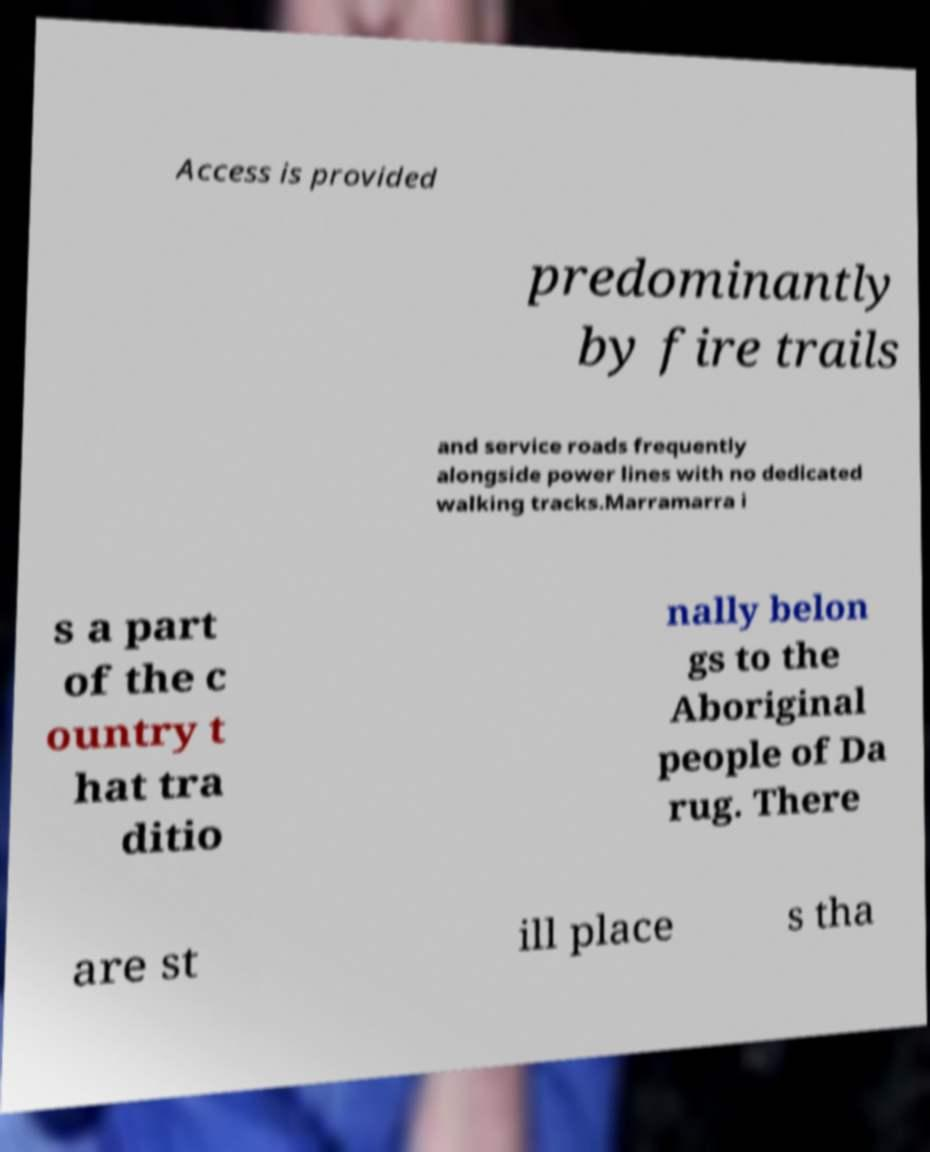What messages or text are displayed in this image? I need them in a readable, typed format. Access is provided predominantly by fire trails and service roads frequently alongside power lines with no dedicated walking tracks.Marramarra i s a part of the c ountry t hat tra ditio nally belon gs to the Aboriginal people of Da rug. There are st ill place s tha 